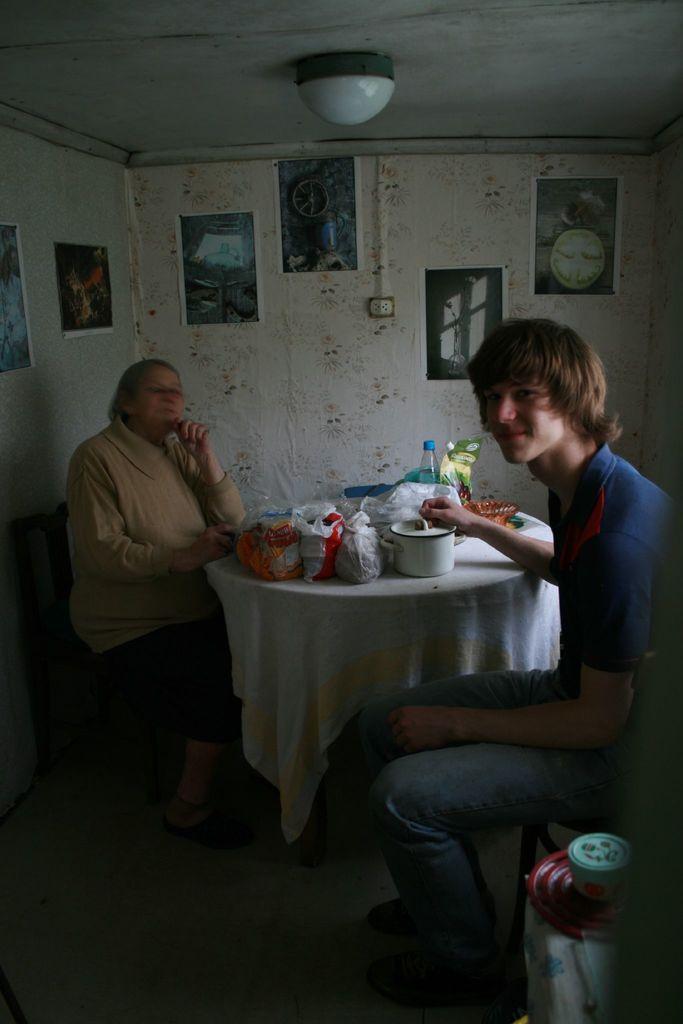Could you give a brief overview of what you see in this image? In the picture there are two persons sitting on the chair with the table in front of them, on the table there are boxes, there are polythene covers, bottles, there is a wall, on the wall there many frames present, there is a light on the roof. 